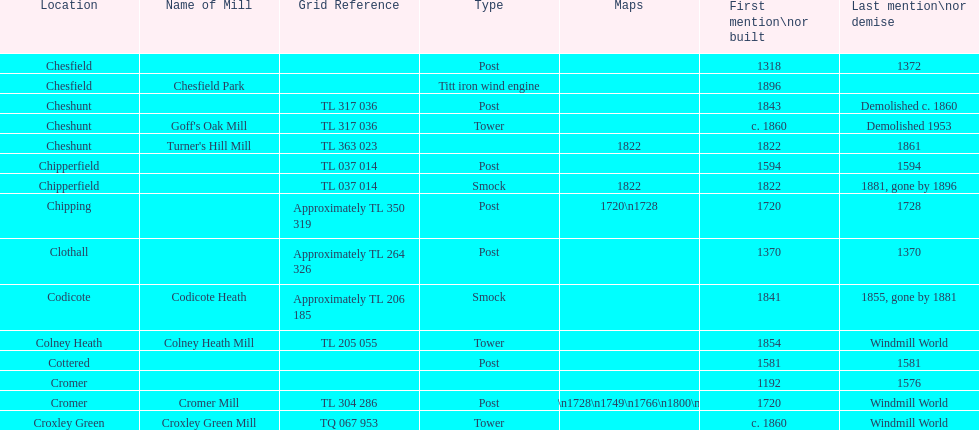Parse the table in full. {'header': ['Location', 'Name of Mill', 'Grid Reference', 'Type', 'Maps', 'First mention\\nor built', 'Last mention\\nor demise'], 'rows': [['Chesfield', '', '', 'Post', '', '1318', '1372'], ['Chesfield', 'Chesfield Park', '', 'Titt iron wind engine', '', '1896', ''], ['Cheshunt', '', 'TL 317 036', 'Post', '', '1843', 'Demolished c. 1860'], ['Cheshunt', "Goff's Oak Mill", 'TL 317 036', 'Tower', '', 'c. 1860', 'Demolished 1953'], ['Cheshunt', "Turner's Hill Mill", 'TL 363 023', '', '1822', '1822', '1861'], ['Chipperfield', '', 'TL 037 014', 'Post', '', '1594', '1594'], ['Chipperfield', '', 'TL 037 014', 'Smock', '1822', '1822', '1881, gone by 1896'], ['Chipping', '', 'Approximately TL 350 319', 'Post', '1720\\n1728', '1720', '1728'], ['Clothall', '', 'Approximately TL 264 326', 'Post', '', '1370', '1370'], ['Codicote', 'Codicote Heath', 'Approximately TL 206 185', 'Smock', '', '1841', '1855, gone by 1881'], ['Colney Heath', 'Colney Heath Mill', 'TL 205 055', 'Tower', '', '1854', 'Windmill World'], ['Cottered', '', '', 'Post', '', '1581', '1581'], ['Cromer', '', '', '', '', '1192', '1576'], ['Cromer', 'Cromer Mill', 'TL 304 286', 'Post', '1720\\n1728\\n1749\\n1766\\n1800\\n1822', '1720', 'Windmill World'], ['Croxley Green', 'Croxley Green Mill', 'TQ 067 953', 'Tower', '', 'c. 1860', 'Windmill World']]} How many mills were built or first mentioned after 1800? 8. 